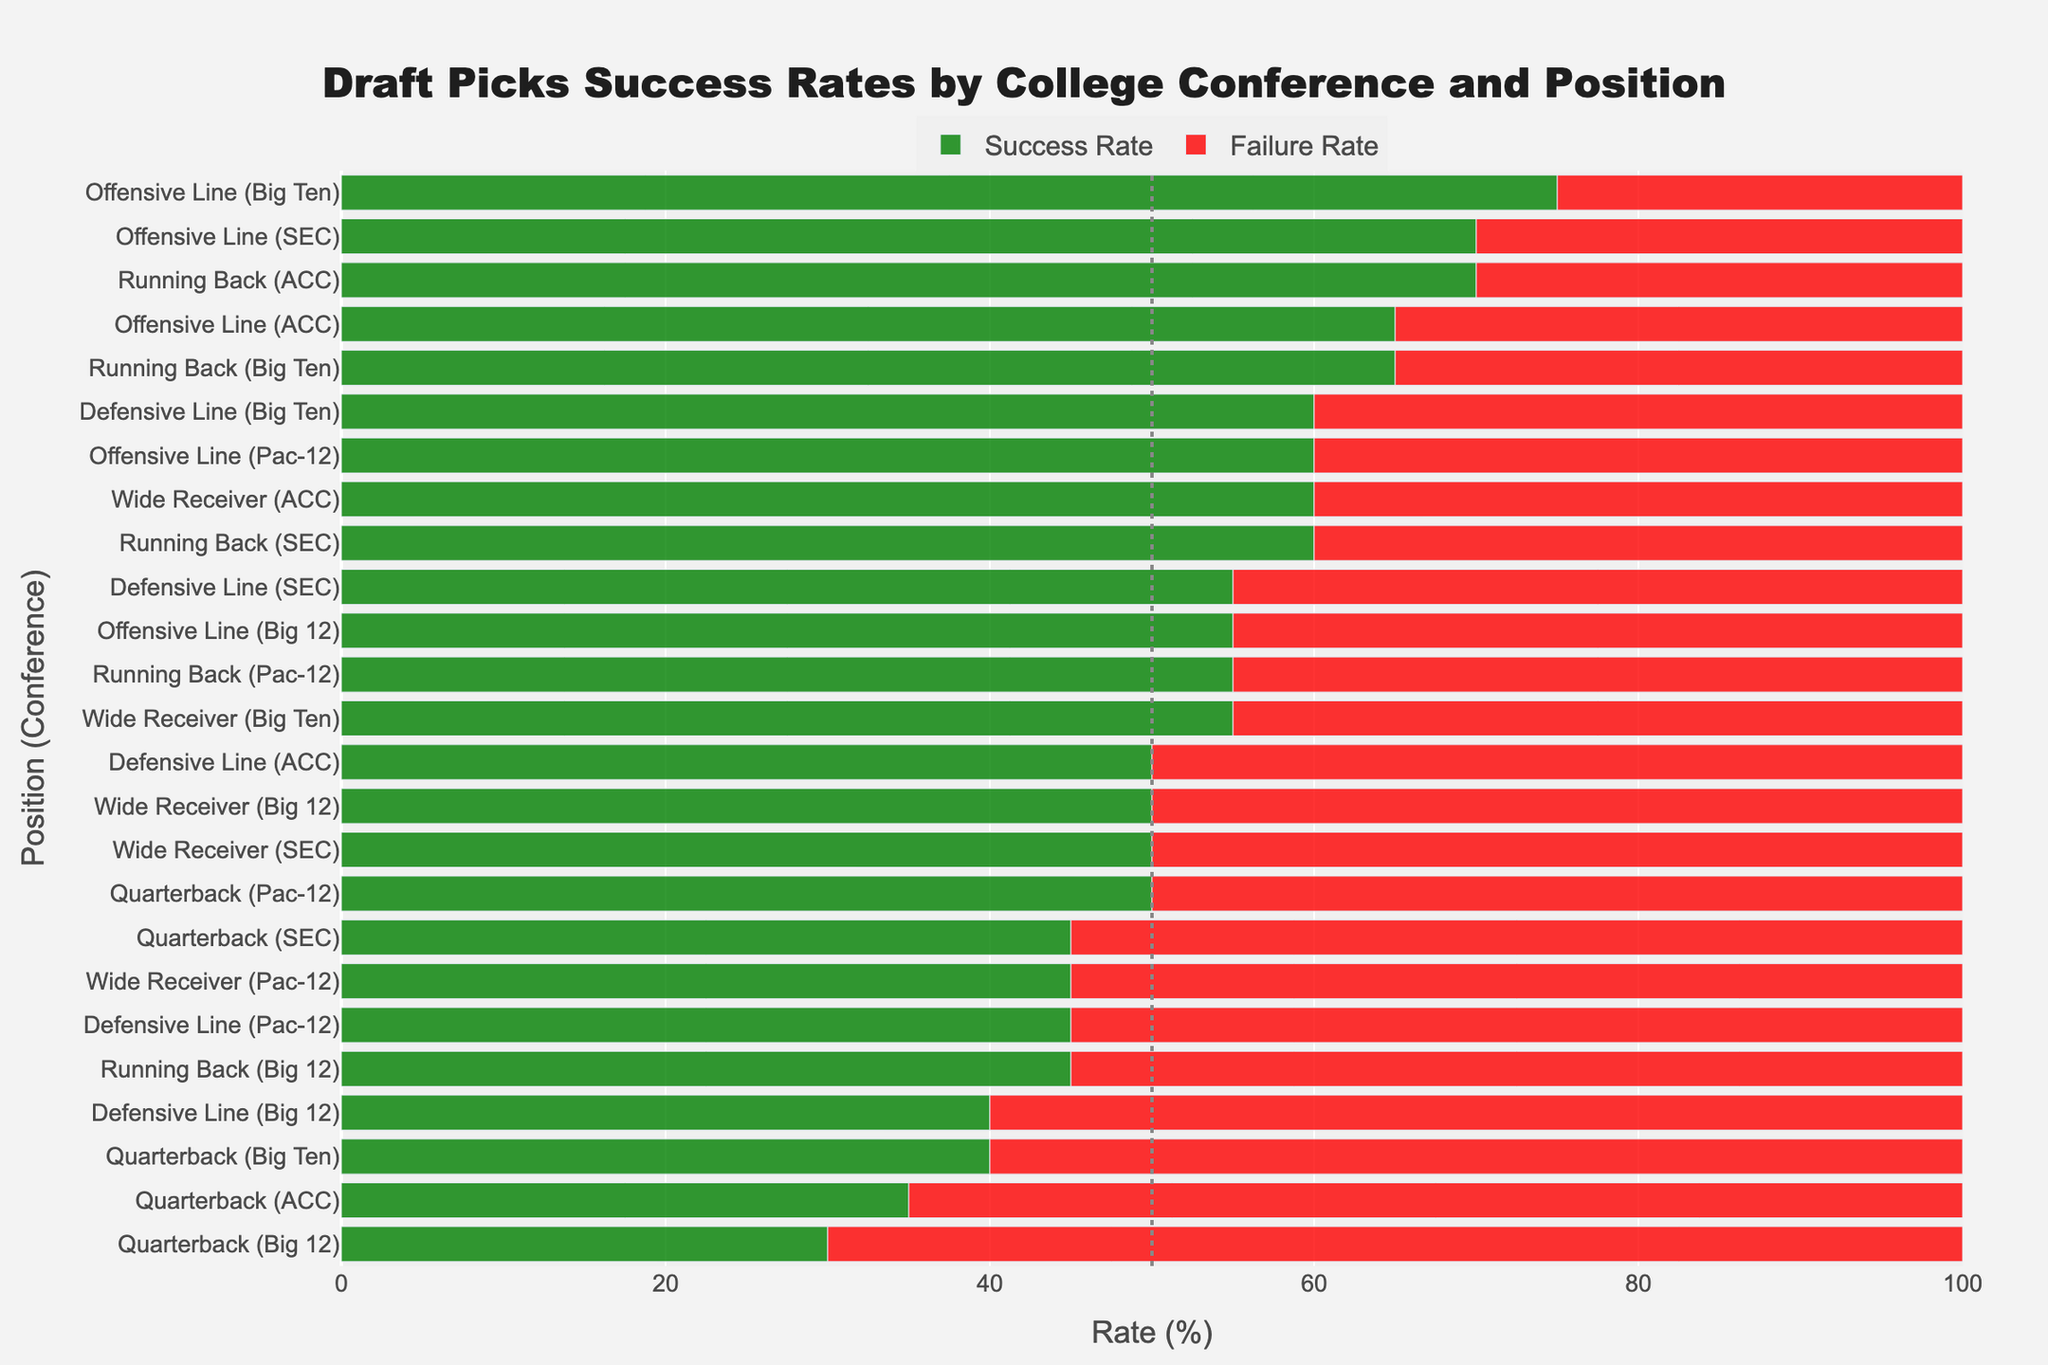Which position from the SEC has the highest success rate? From the SEC, the Running Back position has a 60% success rate, and Offensive Line has a 70% success rate. Comparing them, Offensive Line has the highest success rate.
Answer: Offensive Line What is the difference between the success rates of Big Ten Running Backs and SEC Running Backs? The success rate for Big Ten Running Backs is 65%, while for SEC Running Backs, it is 60%. The difference in success rates is 65% - 60% = 5%.
Answer: 5% Which conference has the highest failure rate for Quarterbacks? For Quarterbacks, the SEC has a 55% failure rate, Big Ten has a 60% failure rate, ACC has a 65% failure rate, Pac-12 has a 50% failure rate, and Big 12 has a 70% failure rate. The Big 12 has the highest failure rate.
Answer: Big 12 Are there any positions where the success rate and failure rate are equal? Only PAC-12 Quarterback and SEC Wide Receiver have bars that reach the 50% marker for both success and failure rates.
Answer: PAC-12 Quarterback, SEC Wide Receiver What is the total success rate for all Offensive Line positions across all conferences? SEC Offensive Line: 70%, Big Ten Offensive Line: 75%, ACC Offensive Line: 65%, Pac-12 Offensive Line: 60%, Big 12 Offensive Line: 55%. Adding them together: 70 + 75 + 65 + 60 + 55 = 325%
Answer: 325% Which position has the lowest success rate in the ACC? For the ACC, Quarterback success rate is 35%, Wide Receiver success rate is 60%, Running Back success rate is 70%, Offensive Line success rate is 65%, and Defensive Line success rate is 50%. The Quarterback has the lowest success rate.
Answer: Quarterback Compare the success rates of Wide Receivers in the ACC and the PAC-12. Which one is higher? The ACC Wide Receivers have a 60% success rate, while the PAC-12 Wide Receivers have a 45% success rate. The ACC has a higher success rate.
Answer: ACC How does the success rate for offensive linemen in the Big Ten compare to that in the SEC? The success rate for SEC Offensive Linemen is 70% and for Big Ten Offensive Linemen is 75%. The success rate in the Big Ten is higher.
Answer: Big Ten What is the range of success rates for Quarterbacks across all conferences? The success rates for Quarterbacks are: SEC: 45%, Big Ten: 40%, ACC: 35%, Pac-12: 50%, Big 12: 30%. The range is 50% - 30% = 20%.
Answer: 20% Which position in the Big 12 has the same success and failure rates? In the Big 12, Wide Receiver has a 50% success and 50% failure rate.
Answer: Wide Receiver 